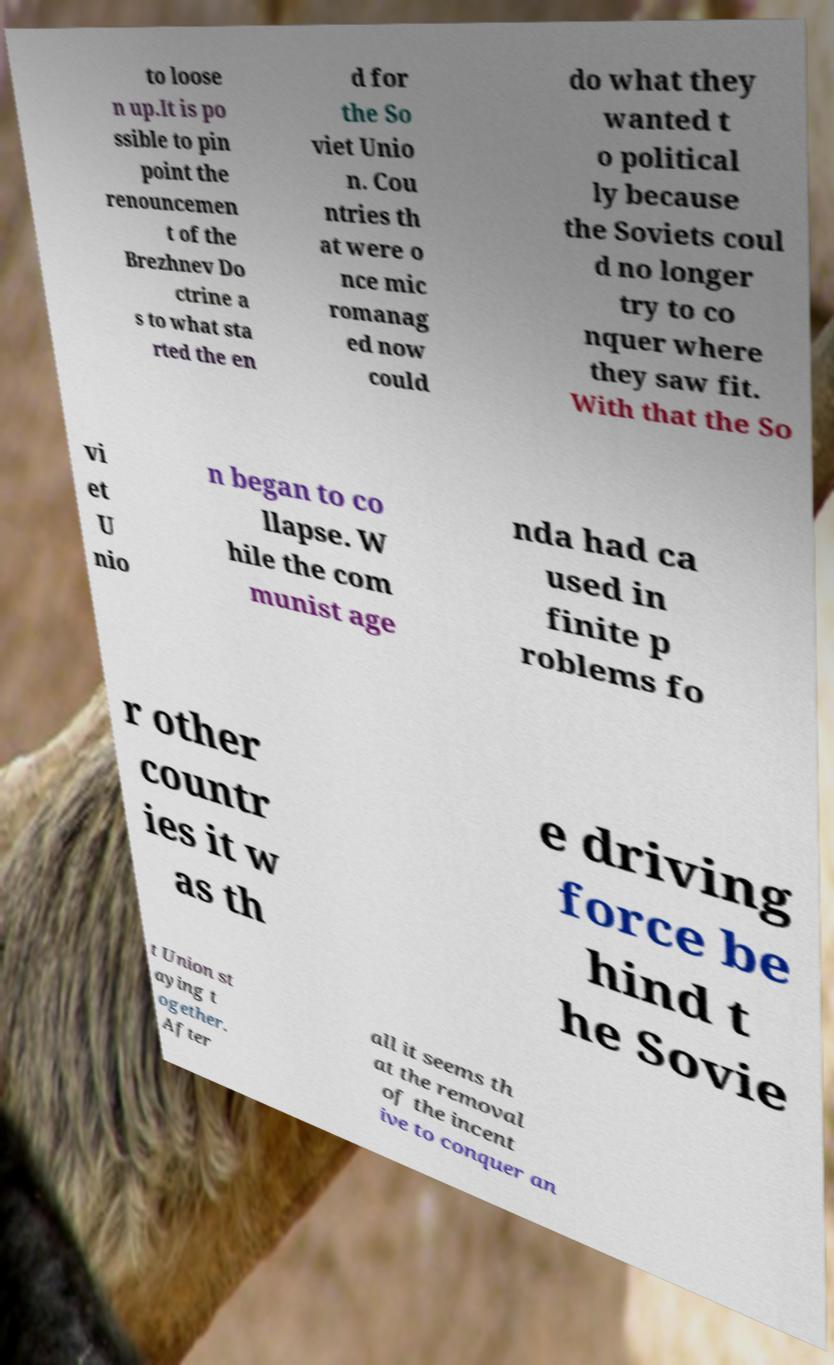Can you read and provide the text displayed in the image?This photo seems to have some interesting text. Can you extract and type it out for me? to loose n up.It is po ssible to pin point the renouncemen t of the Brezhnev Do ctrine a s to what sta rted the en d for the So viet Unio n. Cou ntries th at were o nce mic romanag ed now could do what they wanted t o political ly because the Soviets coul d no longer try to co nquer where they saw fit. With that the So vi et U nio n began to co llapse. W hile the com munist age nda had ca used in finite p roblems fo r other countr ies it w as th e driving force be hind t he Sovie t Union st aying t ogether. After all it seems th at the removal of the incent ive to conquer an 